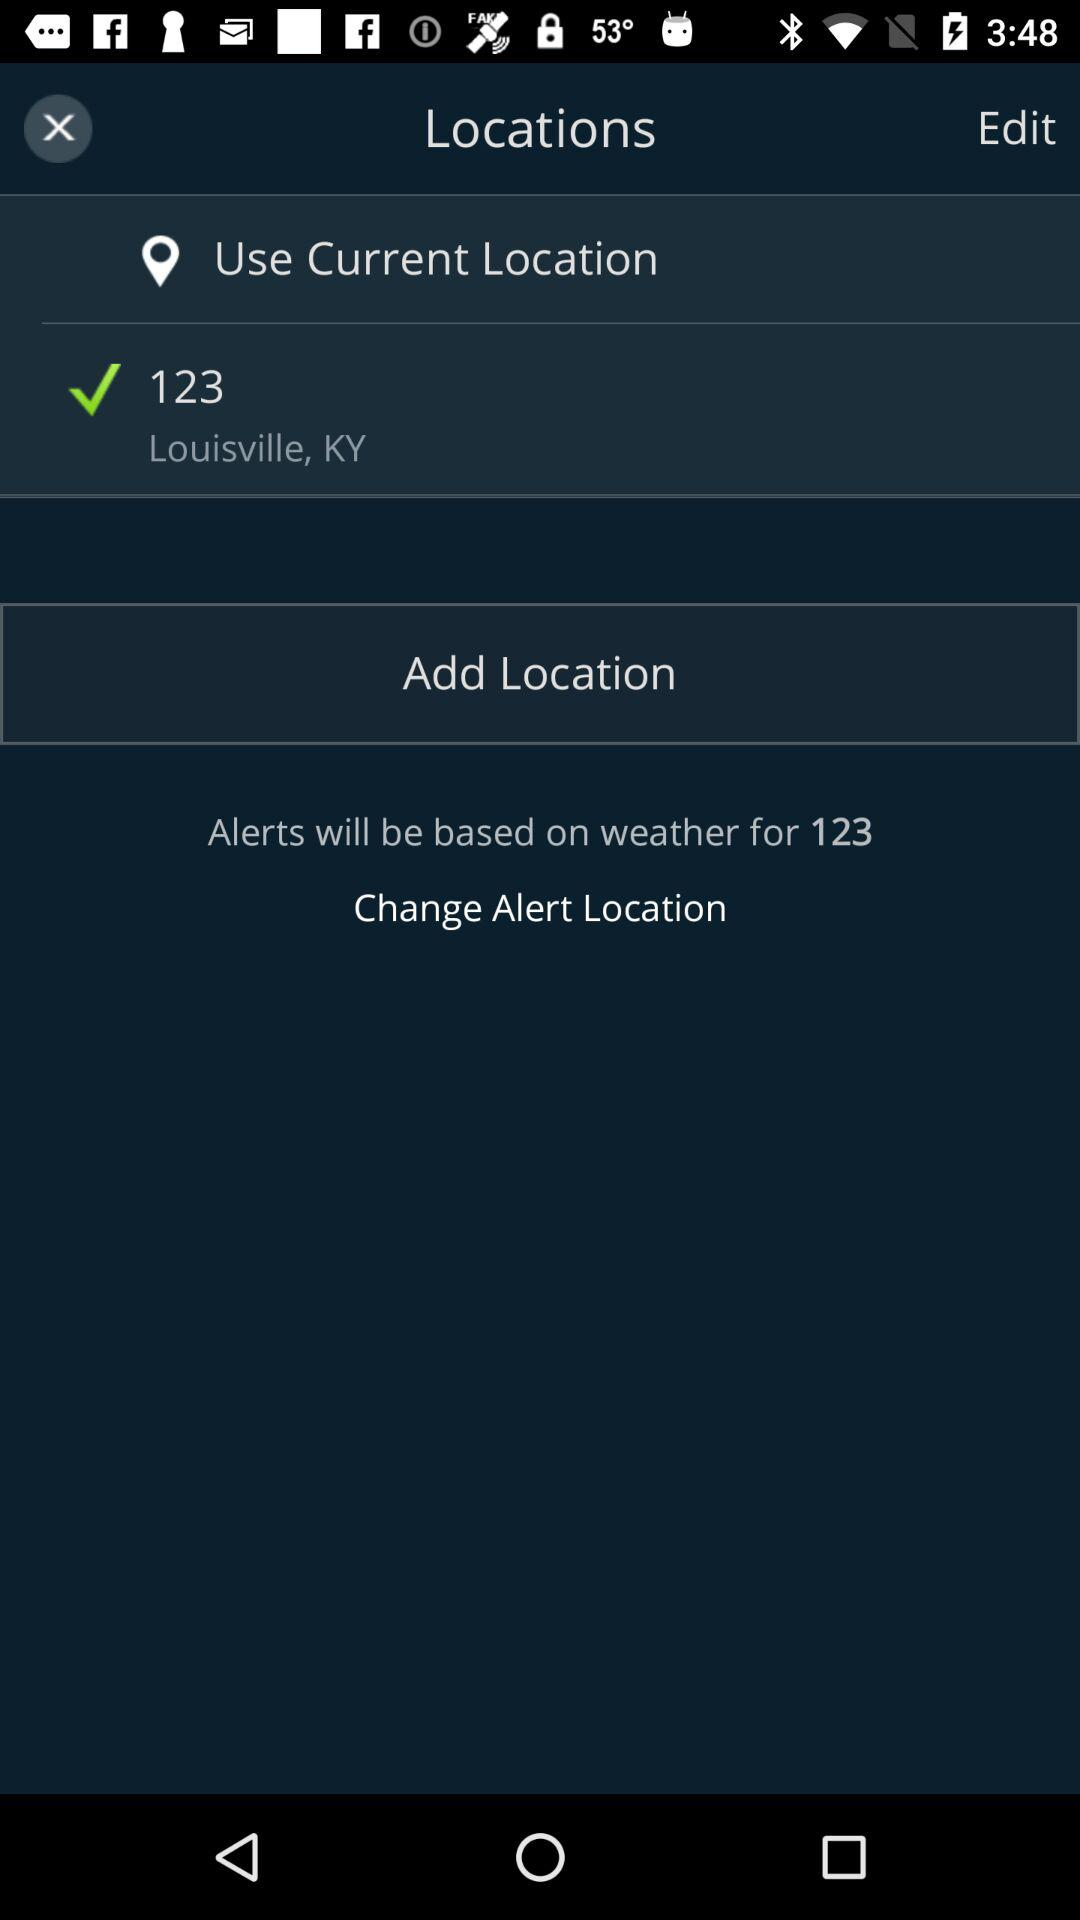When was the alert location changed?
When the provided information is insufficient, respond with <no answer>. <no answer> 